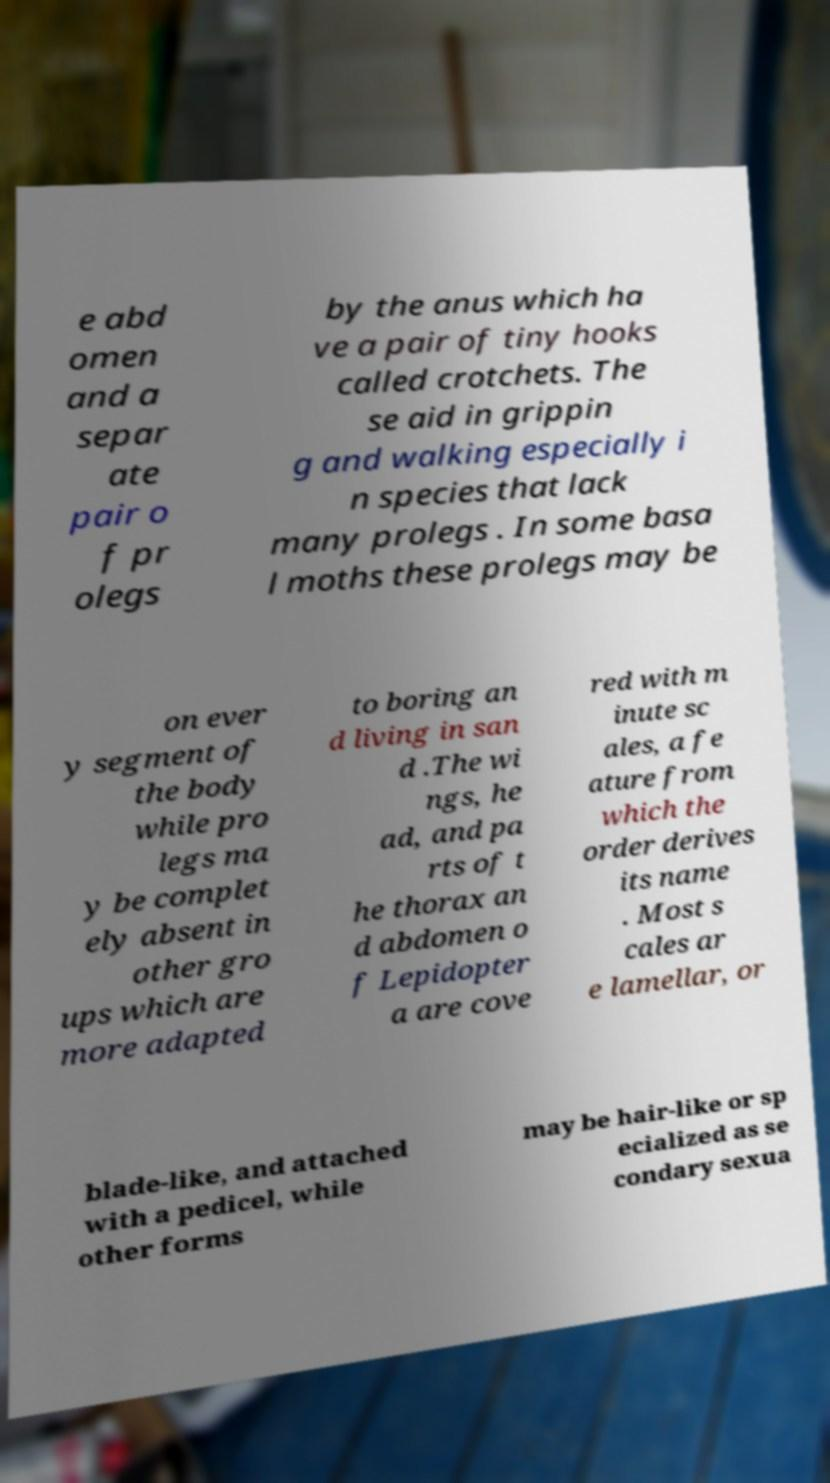Can you read and provide the text displayed in the image?This photo seems to have some interesting text. Can you extract and type it out for me? e abd omen and a separ ate pair o f pr olegs by the anus which ha ve a pair of tiny hooks called crotchets. The se aid in grippin g and walking especially i n species that lack many prolegs . In some basa l moths these prolegs may be on ever y segment of the body while pro legs ma y be complet ely absent in other gro ups which are more adapted to boring an d living in san d .The wi ngs, he ad, and pa rts of t he thorax an d abdomen o f Lepidopter a are cove red with m inute sc ales, a fe ature from which the order derives its name . Most s cales ar e lamellar, or blade-like, and attached with a pedicel, while other forms may be hair-like or sp ecialized as se condary sexua 